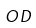Convert formula to latex. <formula><loc_0><loc_0><loc_500><loc_500>O D</formula> 